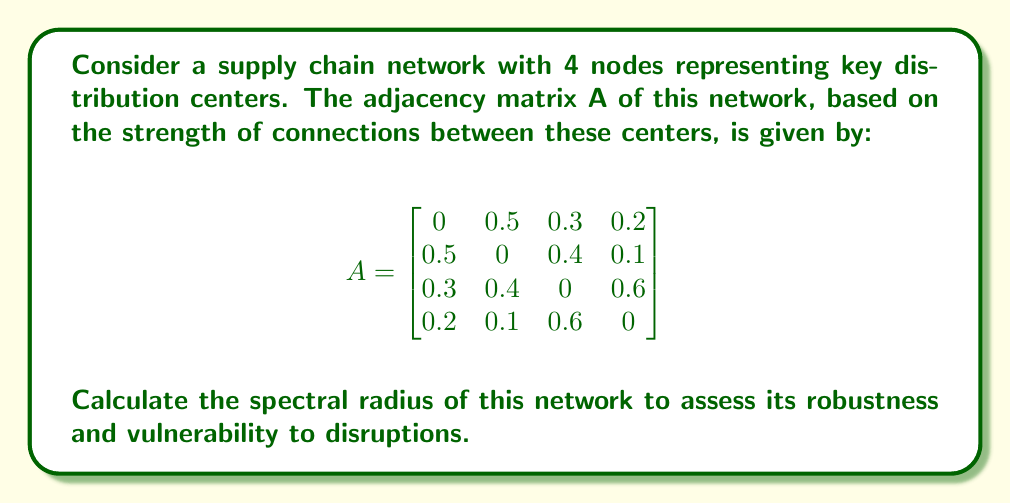Solve this math problem. To determine the spectral radius of the supply chain network, we need to follow these steps:

1) The spectral radius is defined as the largest absolute value of the eigenvalues of the adjacency matrix A.

2) To find the eigenvalues, we need to solve the characteristic equation:
   $$\det(A - \lambda I) = 0$$
   where $I$ is the 4x4 identity matrix and $\lambda$ represents the eigenvalues.

3) Expanding this determinant gives us the characteristic polynomial:
   $$\lambda^4 - 0.77\lambda^2 - 0.2736 = 0$$

4) This is a quadratic equation in $\lambda^2$. Let $u = \lambda^2$, then we have:
   $$u^2 - 0.77u - 0.2736 = 0$$

5) Using the quadratic formula, we can solve for u:
   $$u = \frac{0.77 \pm \sqrt{0.77^2 + 4(0.2736)}}{2}$$

6) This gives us:
   $$u_1 = 0.9836, u_2 = -0.2136$$

7) Since $u = \lambda^2$, we take the square root to find $\lambda$:
   $$\lambda = \pm\sqrt{0.9836}, \pm\sqrt{-0.2136}$$

8) This gives us four eigenvalues:
   $$\lambda_1 = 0.9918, \lambda_2 = -0.9918, \lambda_3 = 0.4622i, \lambda_4 = -0.4622i$$

9) The spectral radius is the largest absolute value among these eigenvalues, which is 0.9918.

This spectral radius being close to 1 indicates that the network is relatively robust, but also suggests some vulnerability to disruptions due to its proximity to the critical value of 1.
Answer: 0.9918 